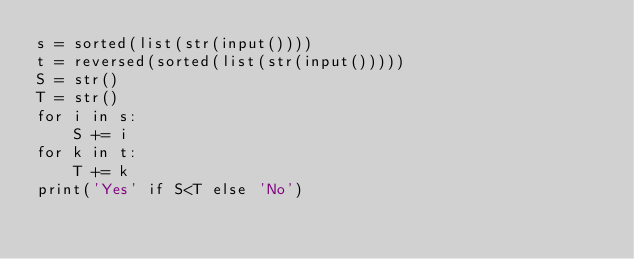Convert code to text. <code><loc_0><loc_0><loc_500><loc_500><_Python_>s = sorted(list(str(input())))
t = reversed(sorted(list(str(input()))))
S = str()
T = str()
for i in s:
    S += i
for k in t:
    T += k
print('Yes' if S<T else 'No')</code> 